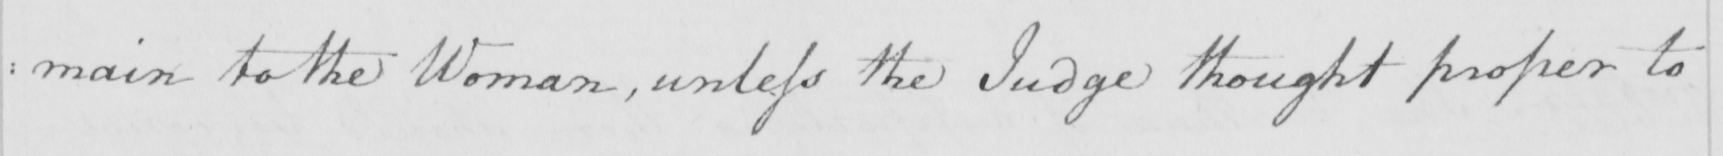Please transcribe the handwritten text in this image. : main to the Woman , unless the Judge thought proper to 